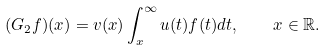Convert formula to latex. <formula><loc_0><loc_0><loc_500><loc_500>( G _ { 2 } f ) ( x ) = v ( x ) \int _ { x } ^ { \infty } u ( t ) f ( t ) d t , \quad x \in \mathbb { R } .</formula> 